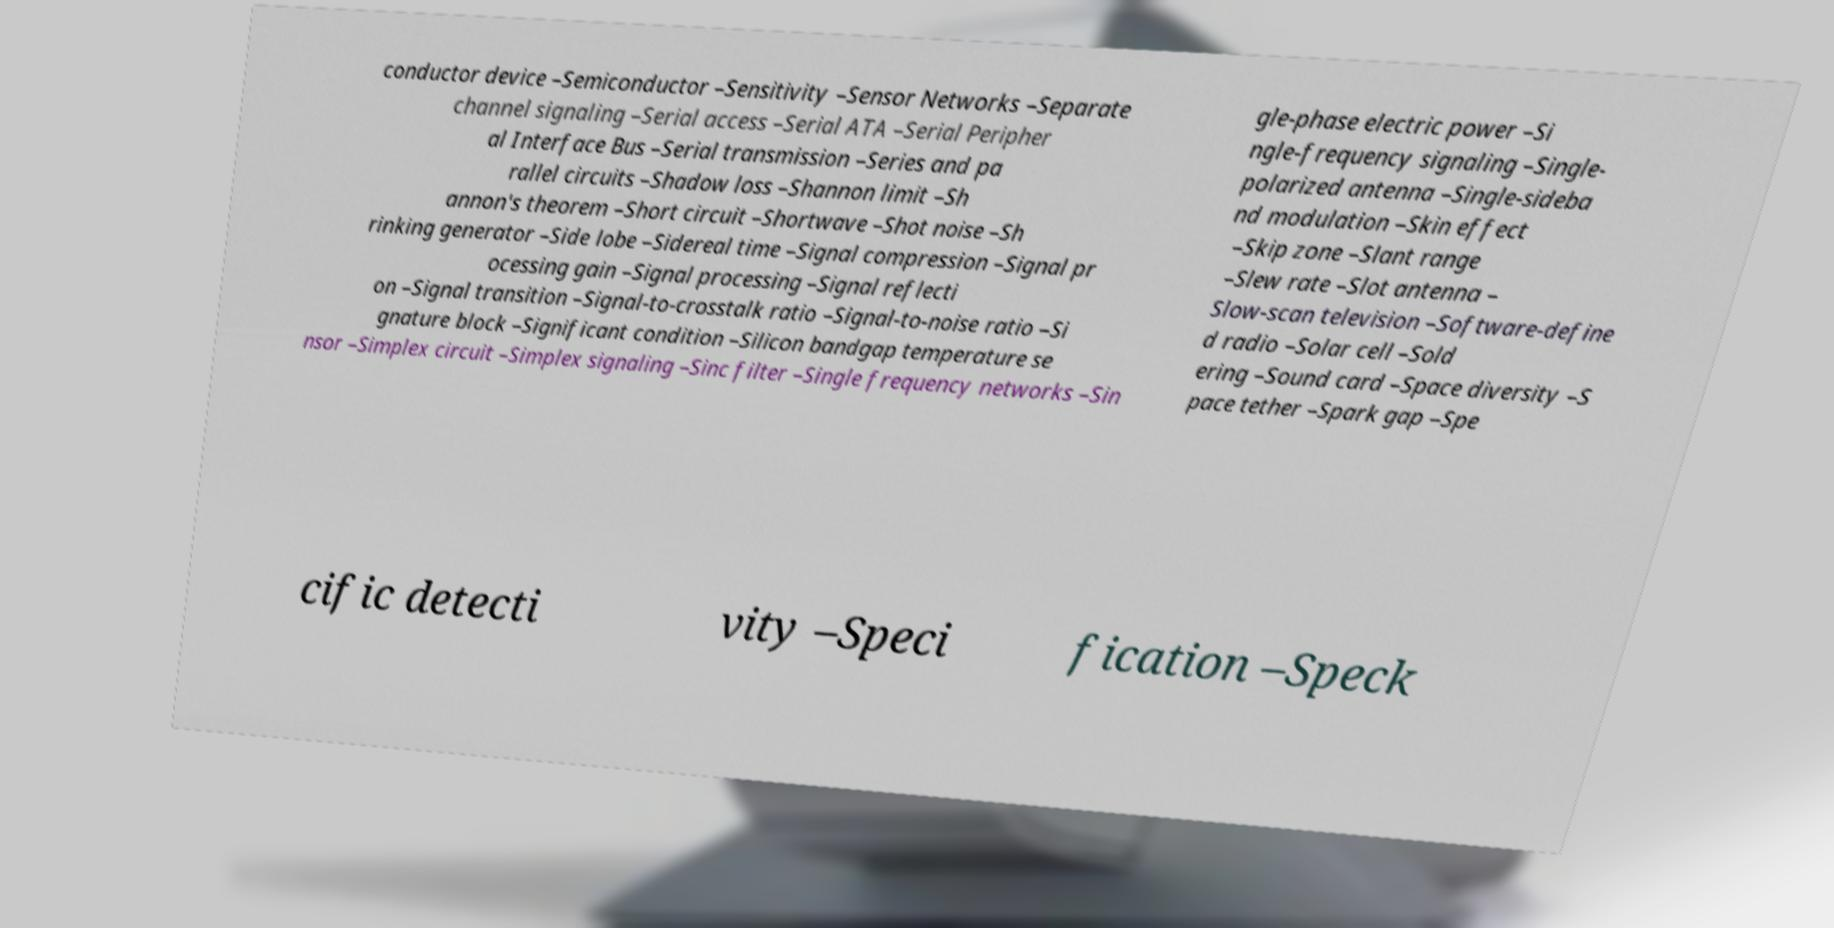There's text embedded in this image that I need extracted. Can you transcribe it verbatim? conductor device –Semiconductor –Sensitivity –Sensor Networks –Separate channel signaling –Serial access –Serial ATA –Serial Peripher al Interface Bus –Serial transmission –Series and pa rallel circuits –Shadow loss –Shannon limit –Sh annon's theorem –Short circuit –Shortwave –Shot noise –Sh rinking generator –Side lobe –Sidereal time –Signal compression –Signal pr ocessing gain –Signal processing –Signal reflecti on –Signal transition –Signal-to-crosstalk ratio –Signal-to-noise ratio –Si gnature block –Significant condition –Silicon bandgap temperature se nsor –Simplex circuit –Simplex signaling –Sinc filter –Single frequency networks –Sin gle-phase electric power –Si ngle-frequency signaling –Single- polarized antenna –Single-sideba nd modulation –Skin effect –Skip zone –Slant range –Slew rate –Slot antenna – Slow-scan television –Software-define d radio –Solar cell –Sold ering –Sound card –Space diversity –S pace tether –Spark gap –Spe cific detecti vity –Speci fication –Speck 